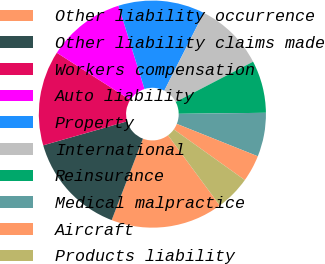Convert chart to OTSL. <chart><loc_0><loc_0><loc_500><loc_500><pie_chart><fcel>Other liability occurrence<fcel>Other liability claims made<fcel>Workers compensation<fcel>Auto liability<fcel>Property<fcel>International<fcel>Reinsurance<fcel>Medical malpractice<fcel>Aircraft<fcel>Products liability<nl><fcel>15.95%<fcel>14.73%<fcel>13.52%<fcel>11.09%<fcel>12.31%<fcel>9.88%<fcel>7.45%<fcel>6.24%<fcel>3.81%<fcel>5.02%<nl></chart> 